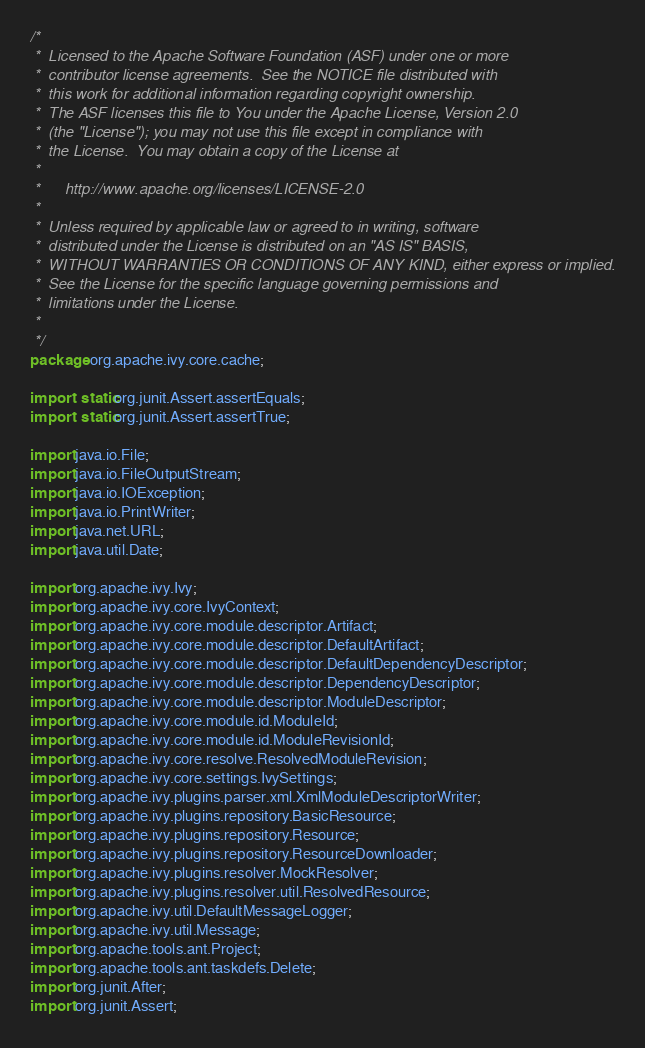Convert code to text. <code><loc_0><loc_0><loc_500><loc_500><_Java_>/*
 *  Licensed to the Apache Software Foundation (ASF) under one or more
 *  contributor license agreements.  See the NOTICE file distributed with
 *  this work for additional information regarding copyright ownership.
 *  The ASF licenses this file to You under the Apache License, Version 2.0
 *  (the "License"); you may not use this file except in compliance with
 *  the License.  You may obtain a copy of the License at
 *
 *      http://www.apache.org/licenses/LICENSE-2.0
 *
 *  Unless required by applicable law or agreed to in writing, software
 *  distributed under the License is distributed on an "AS IS" BASIS,
 *  WITHOUT WARRANTIES OR CONDITIONS OF ANY KIND, either express or implied.
 *  See the License for the specific language governing permissions and
 *  limitations under the License.
 *
 */
package org.apache.ivy.core.cache;

import static org.junit.Assert.assertEquals;
import static org.junit.Assert.assertTrue;

import java.io.File;
import java.io.FileOutputStream;
import java.io.IOException;
import java.io.PrintWriter;
import java.net.URL;
import java.util.Date;

import org.apache.ivy.Ivy;
import org.apache.ivy.core.IvyContext;
import org.apache.ivy.core.module.descriptor.Artifact;
import org.apache.ivy.core.module.descriptor.DefaultArtifact;
import org.apache.ivy.core.module.descriptor.DefaultDependencyDescriptor;
import org.apache.ivy.core.module.descriptor.DependencyDescriptor;
import org.apache.ivy.core.module.descriptor.ModuleDescriptor;
import org.apache.ivy.core.module.id.ModuleId;
import org.apache.ivy.core.module.id.ModuleRevisionId;
import org.apache.ivy.core.resolve.ResolvedModuleRevision;
import org.apache.ivy.core.settings.IvySettings;
import org.apache.ivy.plugins.parser.xml.XmlModuleDescriptorWriter;
import org.apache.ivy.plugins.repository.BasicResource;
import org.apache.ivy.plugins.repository.Resource;
import org.apache.ivy.plugins.repository.ResourceDownloader;
import org.apache.ivy.plugins.resolver.MockResolver;
import org.apache.ivy.plugins.resolver.util.ResolvedResource;
import org.apache.ivy.util.DefaultMessageLogger;
import org.apache.ivy.util.Message;
import org.apache.tools.ant.Project;
import org.apache.tools.ant.taskdefs.Delete;
import org.junit.After;
import org.junit.Assert;</code> 